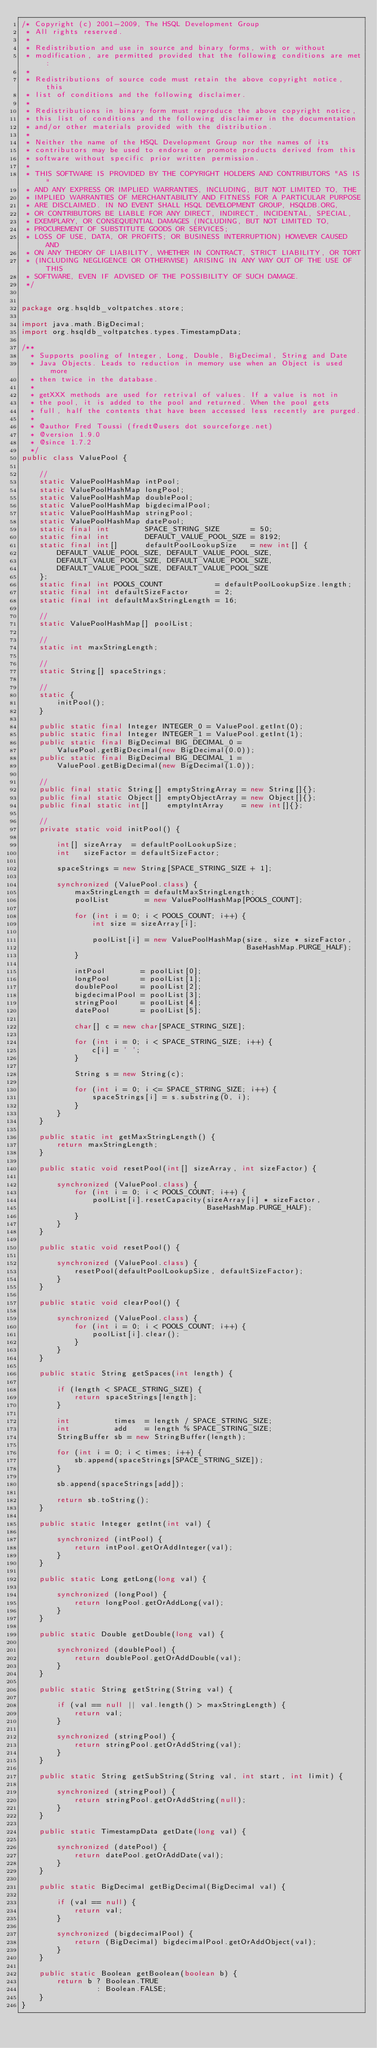Convert code to text. <code><loc_0><loc_0><loc_500><loc_500><_Java_>/* Copyright (c) 2001-2009, The HSQL Development Group
 * All rights reserved.
 *
 * Redistribution and use in source and binary forms, with or without
 * modification, are permitted provided that the following conditions are met:
 *
 * Redistributions of source code must retain the above copyright notice, this
 * list of conditions and the following disclaimer.
 *
 * Redistributions in binary form must reproduce the above copyright notice,
 * this list of conditions and the following disclaimer in the documentation
 * and/or other materials provided with the distribution.
 *
 * Neither the name of the HSQL Development Group nor the names of its
 * contributors may be used to endorse or promote products derived from this
 * software without specific prior written permission.
 *
 * THIS SOFTWARE IS PROVIDED BY THE COPYRIGHT HOLDERS AND CONTRIBUTORS "AS IS"
 * AND ANY EXPRESS OR IMPLIED WARRANTIES, INCLUDING, BUT NOT LIMITED TO, THE
 * IMPLIED WARRANTIES OF MERCHANTABILITY AND FITNESS FOR A PARTICULAR PURPOSE
 * ARE DISCLAIMED. IN NO EVENT SHALL HSQL DEVELOPMENT GROUP, HSQLDB.ORG,
 * OR CONTRIBUTORS BE LIABLE FOR ANY DIRECT, INDIRECT, INCIDENTAL, SPECIAL,
 * EXEMPLARY, OR CONSEQUENTIAL DAMAGES (INCLUDING, BUT NOT LIMITED TO,
 * PROCUREMENT OF SUBSTITUTE GOODS OR SERVICES;
 * LOSS OF USE, DATA, OR PROFITS; OR BUSINESS INTERRUPTION) HOWEVER CAUSED AND
 * ON ANY THEORY OF LIABILITY, WHETHER IN CONTRACT, STRICT LIABILITY, OR TORT
 * (INCLUDING NEGLIGENCE OR OTHERWISE) ARISING IN ANY WAY OUT OF THE USE OF THIS
 * SOFTWARE, EVEN IF ADVISED OF THE POSSIBILITY OF SUCH DAMAGE.
 */


package org.hsqldb_voltpatches.store;

import java.math.BigDecimal;
import org.hsqldb_voltpatches.types.TimestampData;

/**
  * Supports pooling of Integer, Long, Double, BigDecimal, String and Date
  * Java Objects. Leads to reduction in memory use when an Object is used more
  * then twice in the database.
  *
  * getXXX methods are used for retrival of values. If a value is not in
  * the pool, it is added to the pool and returned. When the pool gets
  * full, half the contents that have been accessed less recently are purged.
  *
  * @author Fred Toussi (fredt@users dot sourceforge.net)
  * @version 1.9.0
  * @since 1.7.2
  */
public class ValuePool {

    //
    static ValuePoolHashMap intPool;
    static ValuePoolHashMap longPool;
    static ValuePoolHashMap doublePool;
    static ValuePoolHashMap bigdecimalPool;
    static ValuePoolHashMap stringPool;
    static ValuePoolHashMap datePool;
    static final int        SPACE_STRING_SIZE       = 50;
    static final int        DEFAULT_VALUE_POOL_SIZE = 8192;
    static final int[]      defaultPoolLookupSize   = new int[] {
        DEFAULT_VALUE_POOL_SIZE, DEFAULT_VALUE_POOL_SIZE,
        DEFAULT_VALUE_POOL_SIZE, DEFAULT_VALUE_POOL_SIZE,
        DEFAULT_VALUE_POOL_SIZE, DEFAULT_VALUE_POOL_SIZE
    };
    static final int POOLS_COUNT            = defaultPoolLookupSize.length;
    static final int defaultSizeFactor      = 2;
    static final int defaultMaxStringLength = 16;

    //
    static ValuePoolHashMap[] poolList;

    //
    static int maxStringLength;

    //
    static String[] spaceStrings;

    //
    static {
        initPool();
    }

    public static final Integer INTEGER_0 = ValuePool.getInt(0);
    public static final Integer INTEGER_1 = ValuePool.getInt(1);
    public static final BigDecimal BIG_DECIMAL_0 =
        ValuePool.getBigDecimal(new BigDecimal(0.0));
    public static final BigDecimal BIG_DECIMAL_1 =
        ValuePool.getBigDecimal(new BigDecimal(1.0));

    //
    public final static String[] emptyStringArray = new String[]{};
    public final static Object[] emptyObjectArray = new Object[]{};
    public final static int[]    emptyIntArray    = new int[]{};

    //
    private static void initPool() {

        int[] sizeArray  = defaultPoolLookupSize;
        int   sizeFactor = defaultSizeFactor;

        spaceStrings = new String[SPACE_STRING_SIZE + 1];

        synchronized (ValuePool.class) {
            maxStringLength = defaultMaxStringLength;
            poolList        = new ValuePoolHashMap[POOLS_COUNT];

            for (int i = 0; i < POOLS_COUNT; i++) {
                int size = sizeArray[i];

                poolList[i] = new ValuePoolHashMap(size, size * sizeFactor,
                                                   BaseHashMap.PURGE_HALF);
            }

            intPool        = poolList[0];
            longPool       = poolList[1];
            doublePool     = poolList[2];
            bigdecimalPool = poolList[3];
            stringPool     = poolList[4];
            datePool       = poolList[5];

            char[] c = new char[SPACE_STRING_SIZE];

            for (int i = 0; i < SPACE_STRING_SIZE; i++) {
                c[i] = ' ';
            }

            String s = new String(c);

            for (int i = 0; i <= SPACE_STRING_SIZE; i++) {
                spaceStrings[i] = s.substring(0, i);
            }
        }
    }

    public static int getMaxStringLength() {
        return maxStringLength;
    }

    public static void resetPool(int[] sizeArray, int sizeFactor) {

        synchronized (ValuePool.class) {
            for (int i = 0; i < POOLS_COUNT; i++) {
                poolList[i].resetCapacity(sizeArray[i] * sizeFactor,
                                          BaseHashMap.PURGE_HALF);
            }
        }
    }

    public static void resetPool() {

        synchronized (ValuePool.class) {
            resetPool(defaultPoolLookupSize, defaultSizeFactor);
        }
    }

    public static void clearPool() {

        synchronized (ValuePool.class) {
            for (int i = 0; i < POOLS_COUNT; i++) {
                poolList[i].clear();
            }
        }
    }

    public static String getSpaces(int length) {

        if (length < SPACE_STRING_SIZE) {
            return spaceStrings[length];
        }

        int          times  = length / SPACE_STRING_SIZE;
        int          add    = length % SPACE_STRING_SIZE;
        StringBuffer sb = new StringBuffer(length);

        for (int i = 0; i < times; i++) {
            sb.append(spaceStrings[SPACE_STRING_SIZE]);
        }

        sb.append(spaceStrings[add]);

        return sb.toString();
    }

    public static Integer getInt(int val) {

        synchronized (intPool) {
            return intPool.getOrAddInteger(val);
        }
    }

    public static Long getLong(long val) {

        synchronized (longPool) {
            return longPool.getOrAddLong(val);
        }
    }

    public static Double getDouble(long val) {

        synchronized (doublePool) {
            return doublePool.getOrAddDouble(val);
        }
    }

    public static String getString(String val) {

        if (val == null || val.length() > maxStringLength) {
            return val;
        }

        synchronized (stringPool) {
            return stringPool.getOrAddString(val);
        }
    }

    public static String getSubString(String val, int start, int limit) {

        synchronized (stringPool) {
            return stringPool.getOrAddString(null);
        }
    }

    public static TimestampData getDate(long val) {

        synchronized (datePool) {
            return datePool.getOrAddDate(val);
        }
    }

    public static BigDecimal getBigDecimal(BigDecimal val) {

        if (val == null) {
            return val;
        }

        synchronized (bigdecimalPool) {
            return (BigDecimal) bigdecimalPool.getOrAddObject(val);
        }
    }

    public static Boolean getBoolean(boolean b) {
        return b ? Boolean.TRUE
                 : Boolean.FALSE;
    }
}
</code> 